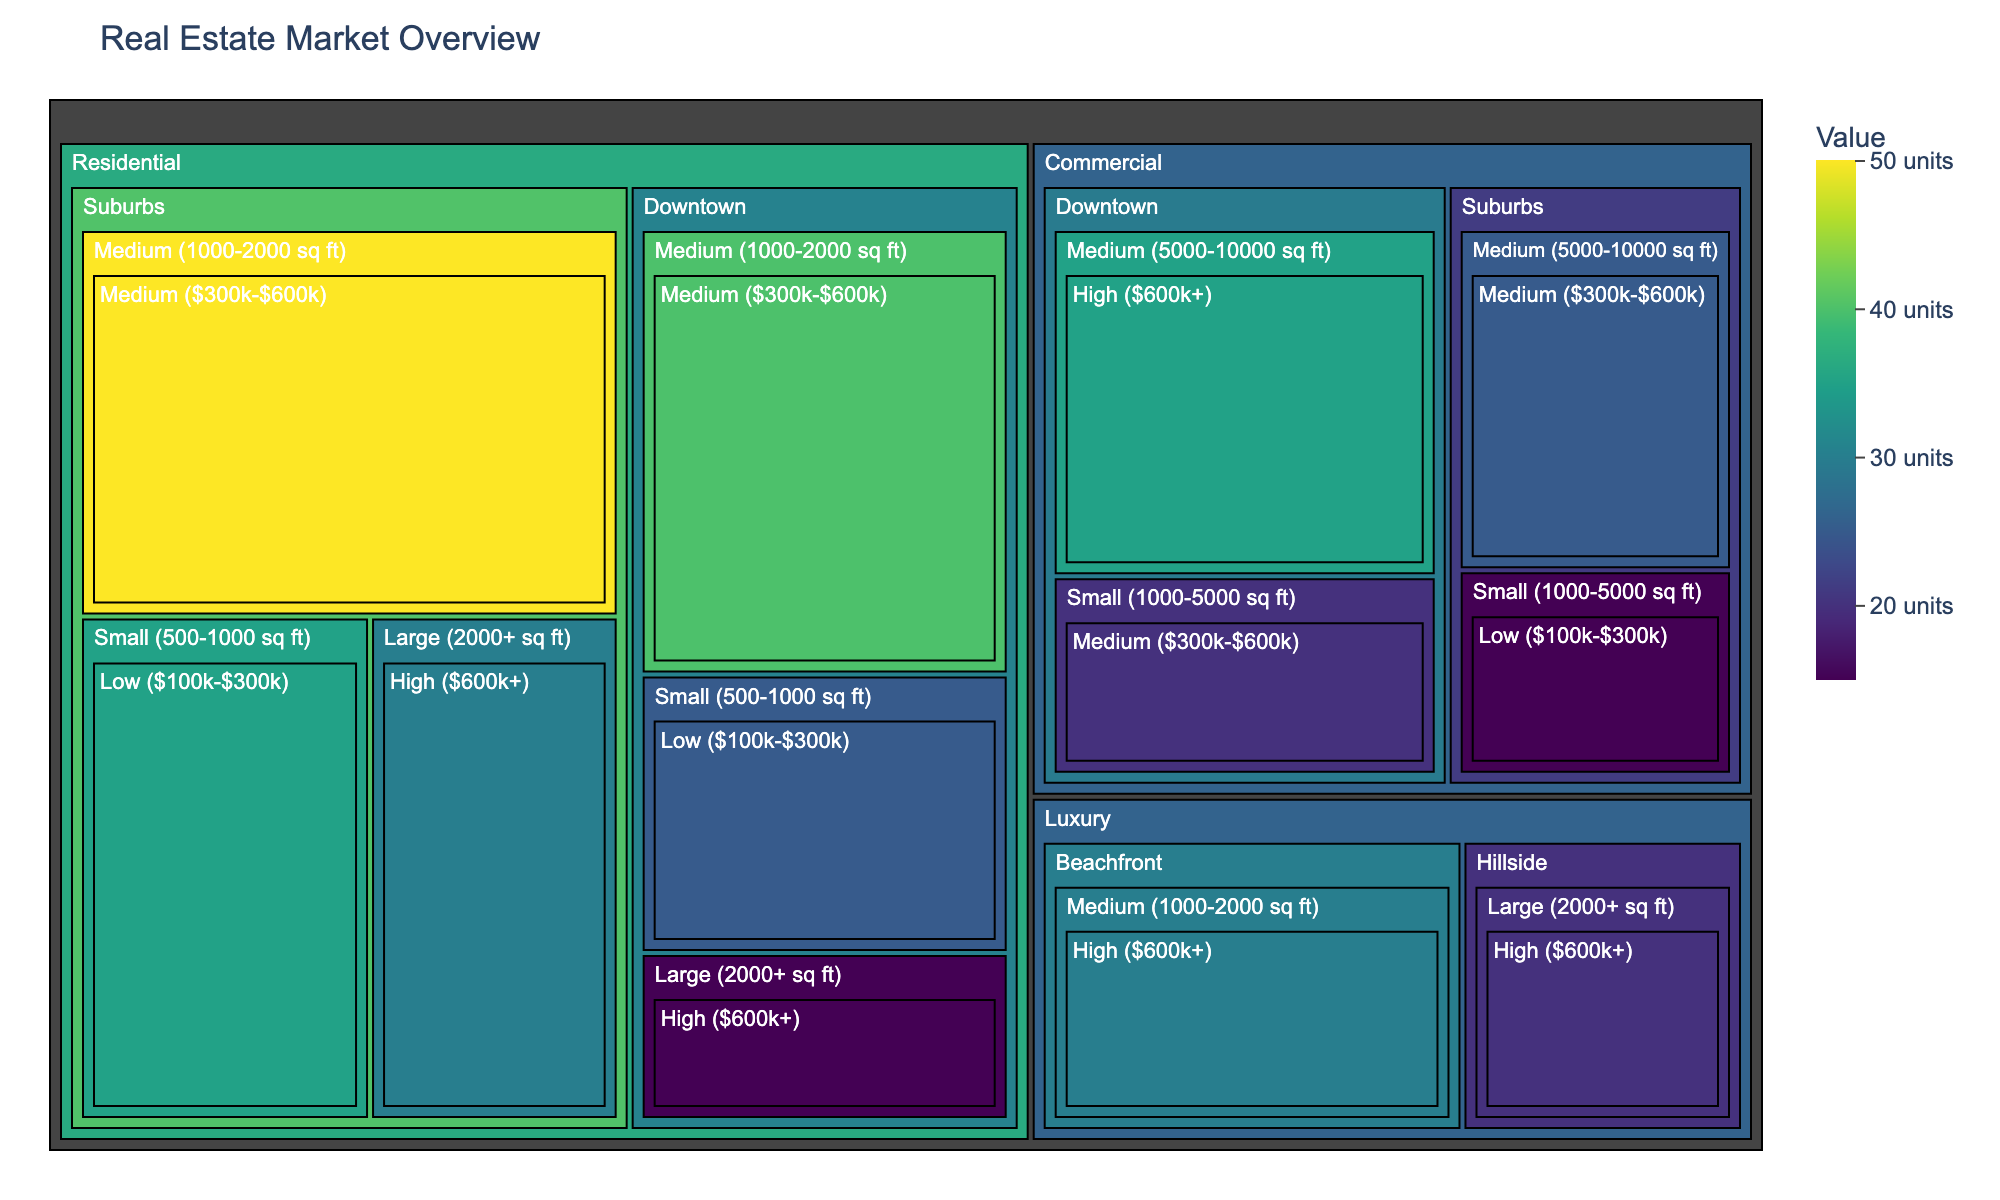Which property type in the Downtown location has the highest value? To find the property type in the Downtown location with the highest value, compare the values for Residential and Commercial properties. Residential (Medium size) has 40 units, Residential (Small size) has 25 units, Residential (Large size) has 15 units, while Commercial (Medium size) has 35 units and Commercial (Small size) has 20 units. The highest is 40 units for Residential (Medium size).
Answer: Residential (Medium size) How does the value for Medium-sized residential properties in the Suburbs compare with Medium-sized commercial properties in the Suburbs? In the Suburbs, the value for Medium-sized residential properties is 50 units, whereas for Medium-sized commercial properties, it is 25 units. Comparing these values, Medium-sized residential properties are higher by 25 units.
Answer: Residential properties have 25 more units What's the total value of all residential properties in the Suburbs? Sum the values for all residential property sizes in the Suburbs: Small (35 units), Medium (50 units), and Large (30 units). The total value is 35 + 50 + 30 = 115 units.
Answer: 115 units Which location has the highest overall value for residential properties? Compare the total values for residential properties in each location. Downtown has 25 (Small) + 40 (Medium) + 15 (Large) = 80 units, while Suburbs has 35 (Small) + 50 (Medium) + 30 (Large) = 115 units. The Suburbs have the highest overall value.
Answer: Suburbs What is the value difference between Small-sized residential and commercial properties in the Downtown location? Determine the value for Small-sized residential (25 units) and commercial (20 units) properties in Downtown. The difference is 25 - 20 = 5 units.
Answer: 5 units Which property type has the highest value in the Beachfront location? Check the values for all property types in Beachfront. For Luxury properties of Medium size, the value is 30 units. As there is only one category listed, this is the highest by default.
Answer: Luxury (Medium size) How does the value of Large-sized residential properties in the Suburbs compare to Large-sized luxury properties in the Hillside location? Large-sized residential properties in the Suburbs have a value of 30 units, while Large-sized luxury properties in Hillside have a value of 20 units. The residential properties are higher by 10 units.
Answer: Suburbs Residential is higher by 10 units What's the combined value of all Medium-sized properties across all locations? Sum the values of medium-sized properties: Residential in Downtown (40), Residential in Suburbs (50), Commercial in Suburbs (25), and Luxury in Beachfront (30). The total combined value is 40 + 50 + 25 + 30 = 145 units.
Answer: 145 units Among Commercial properties, which location and size combination has the highest value? Compare the values for different combinations of location and size for Commercial properties. Downtown Medium size has 35 units, Downtown Small size has 20 units, Suburbs Medium size has 25 units, and Suburbs Small size has 15 units. The highest value is 35 units for Downtown Medium size.
Answer: Downtown Medium size 